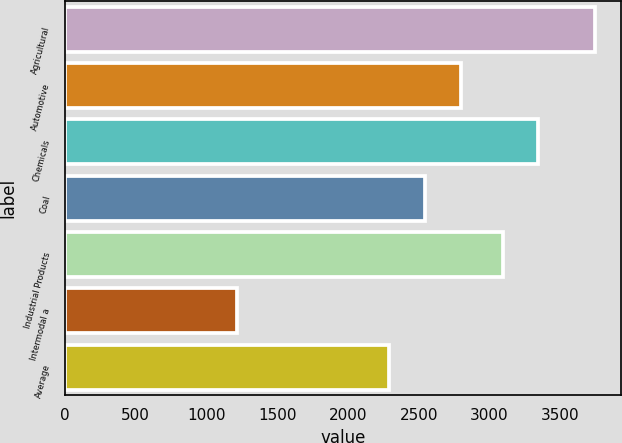Convert chart to OTSL. <chart><loc_0><loc_0><loc_500><loc_500><bar_chart><fcel>Agricultural<fcel>Automotive<fcel>Chemicals<fcel>Coal<fcel>Industrial Products<fcel>Intermodal a<fcel>Average<nl><fcel>3746<fcel>2799.8<fcel>3346.4<fcel>2546.4<fcel>3093<fcel>1212<fcel>2293<nl></chart> 